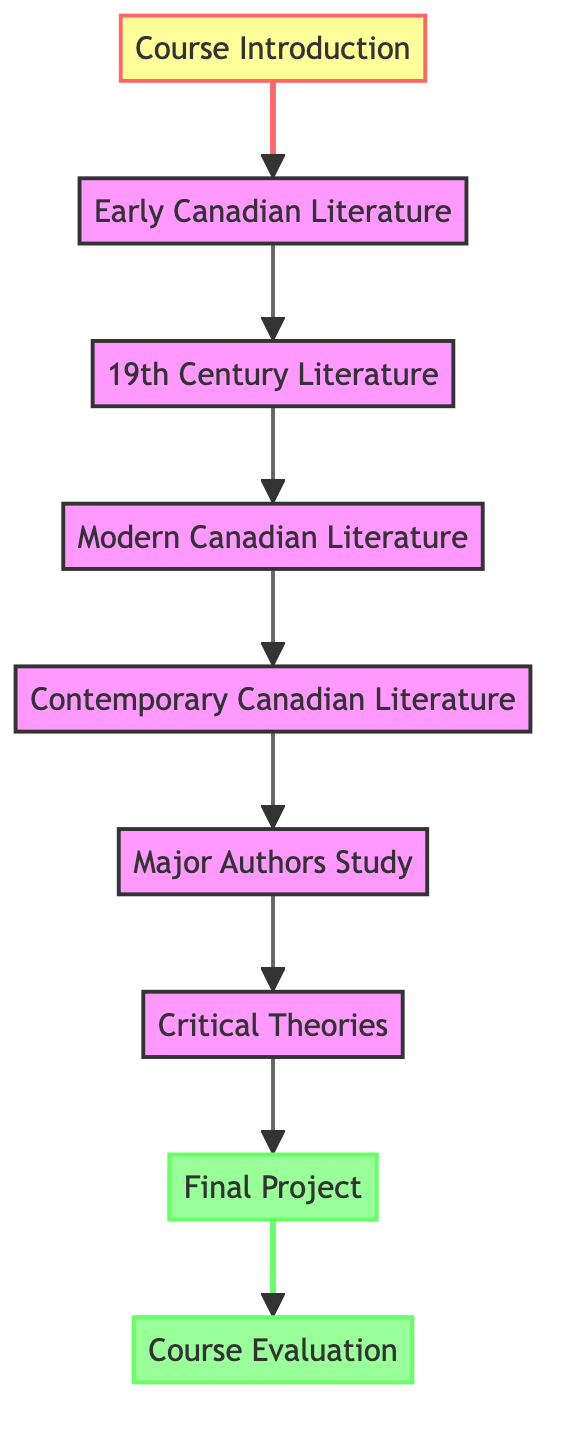What is the first topic studied in the course? The diagram indicates that the first topic is "Course Introduction," as it is the starting node from which all other topics flow.
Answer: Course Introduction How many main topics are there in the course? Counting the nodes listed in the diagram, there are a total of eight main topics covered throughout the course.
Answer: Eight What topic follows "Modern Canadian Literature"? The flow from the node "Modern Canadian Literature" leads directly to the next node "Contemporary Canadian Literature," indicating that this is the following topic in the sequence.
Answer: Contemporary Canadian Literature Which topic precedes "Final Project"? The diagram shows that the node "Critical Theories" directly leads to "Final Project," meaning that "Critical Theories" is the topic studied before the final project.
Answer: Critical Theories What is the last step in the progression before evaluation? The last step before the "Course Evaluation" in the diagram is the "Final Project," which is the final node leading into the evaluation phase.
Answer: Final Project Which topics are studied after "Major Authors Study"? According to the diagram, "Major Authors Study" flows into "Critical Theories," meaning that this is the next topic to study after major authors.
Answer: Critical Theories How many edges are there in this directed graph? By counting all the directed connections (edges) shown in the diagram, there are a total of seven edges representing the progression of topics.
Answer: Seven What is the relationship between "Early Canadian Literature" and "19th Century Literature"? The directed edge from "Early Canadian Literature" to "19th Century Literature" indicates that the former leads into the latter, establishing a direct sequential relationship.
Answer: Direct progression What does the final node represent? The last node in the flow diagram is labeled "Course Evaluation," which signifies the culmination of the course structure where assessment occurs.
Answer: Course Evaluation 